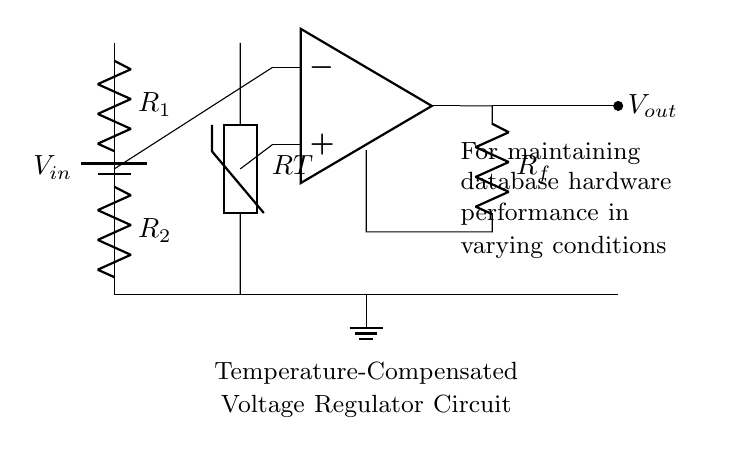What is the component used for temperature sensing? The diagram features a thermistor labeled as RT, which is specifically designed for temperature sensing by changing resistance based on temperature variations.
Answer: thermistor What is the purpose of the operational amplifier in this circuit? The operational amplifier in the circuit is used to amplify the voltage difference between its inputs, which is necessary for adjusting the output voltage based on the sensed temperature from the thermistor.
Answer: amplification Which resistor is part of the voltage divider? The circuit diagram shows two resistors, R1 and R2, connected in series between the input voltage and ground, creating a voltage divider to determine the reference voltage.
Answer: R1, R2 How does Rf contribute to the regulator's performance? Rf is part of the feedback loop connected to the output of the operational amplifier, allowing the circuit to maintain the desired output voltage by adjusting based on the difference detected at the amplifier inputs, effectively stabilizing the output.
Answer: Feedback stabilization What does the term "temperature-compensated" imply regarding this circuit? "Temperature-compensated" indicates the regulator is designed to maintain a stable output voltage even when environmental temperatures vary, achieved through the inclusion of a thermistor and the amplification mechanism that responds to temperature changes.
Answer: Stable output voltage 